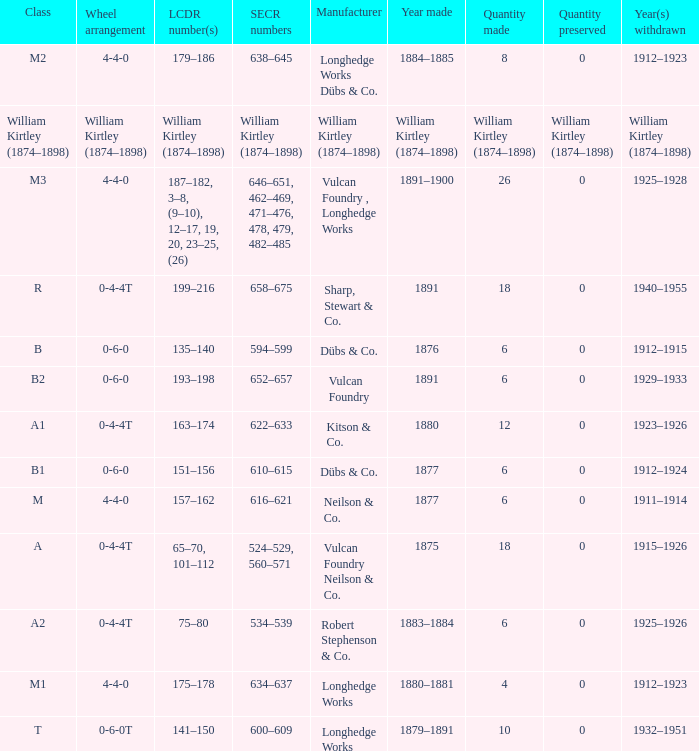Parse the full table. {'header': ['Class', 'Wheel arrangement', 'LCDR number(s)', 'SECR numbers', 'Manufacturer', 'Year made', 'Quantity made', 'Quantity preserved', 'Year(s) withdrawn'], 'rows': [['M2', '4-4-0', '179–186', '638–645', 'Longhedge Works Dübs & Co.', '1884–1885', '8', '0', '1912–1923'], ['William Kirtley (1874–1898)', 'William Kirtley (1874–1898)', 'William Kirtley (1874–1898)', 'William Kirtley (1874–1898)', 'William Kirtley (1874–1898)', 'William Kirtley (1874–1898)', 'William Kirtley (1874–1898)', 'William Kirtley (1874–1898)', 'William Kirtley (1874–1898)'], ['M3', '4-4-0', '187–182, 3–8, (9–10), 12–17, 19, 20, 23–25, (26)', '646–651, 462–469, 471–476, 478, 479, 482–485', 'Vulcan Foundry , Longhedge Works', '1891–1900', '26', '0', '1925–1928'], ['R', '0-4-4T', '199–216', '658–675', 'Sharp, Stewart & Co.', '1891', '18', '0', '1940–1955'], ['B', '0-6-0', '135–140', '594–599', 'Dübs & Co.', '1876', '6', '0', '1912–1915'], ['B2', '0-6-0', '193–198', '652–657', 'Vulcan Foundry', '1891', '6', '0', '1929–1933'], ['A1', '0-4-4T', '163–174', '622–633', 'Kitson & Co.', '1880', '12', '0', '1923–1926'], ['B1', '0-6-0', '151–156', '610–615', 'Dübs & Co.', '1877', '6', '0', '1912–1924'], ['M', '4-4-0', '157–162', '616–621', 'Neilson & Co.', '1877', '6', '0', '1911–1914'], ['A', '0-4-4T', '65–70, 101–112', '524–529, 560–571', 'Vulcan Foundry Neilson & Co.', '1875', '18', '0', '1915–1926'], ['A2', '0-4-4T', '75–80', '534–539', 'Robert Stephenson & Co.', '1883–1884', '6', '0', '1925–1926'], ['M1', '4-4-0', '175–178', '634–637', 'Longhedge Works', '1880–1881', '4', '0', '1912–1923'], ['T', '0-6-0T', '141–150', '600–609', 'Longhedge Works', '1879–1891', '10', '0', '1932–1951']]} Which SECR numbers have a class of b1? 610–615. 